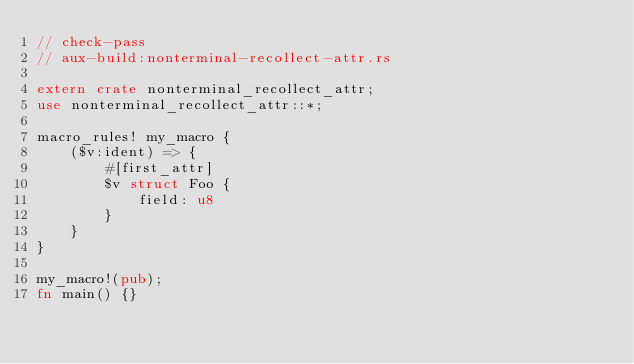Convert code to text. <code><loc_0><loc_0><loc_500><loc_500><_Rust_>// check-pass
// aux-build:nonterminal-recollect-attr.rs

extern crate nonterminal_recollect_attr;
use nonterminal_recollect_attr::*;

macro_rules! my_macro {
    ($v:ident) => {
        #[first_attr]
        $v struct Foo {
            field: u8
        }
    }
}

my_macro!(pub);
fn main() {}
</code> 